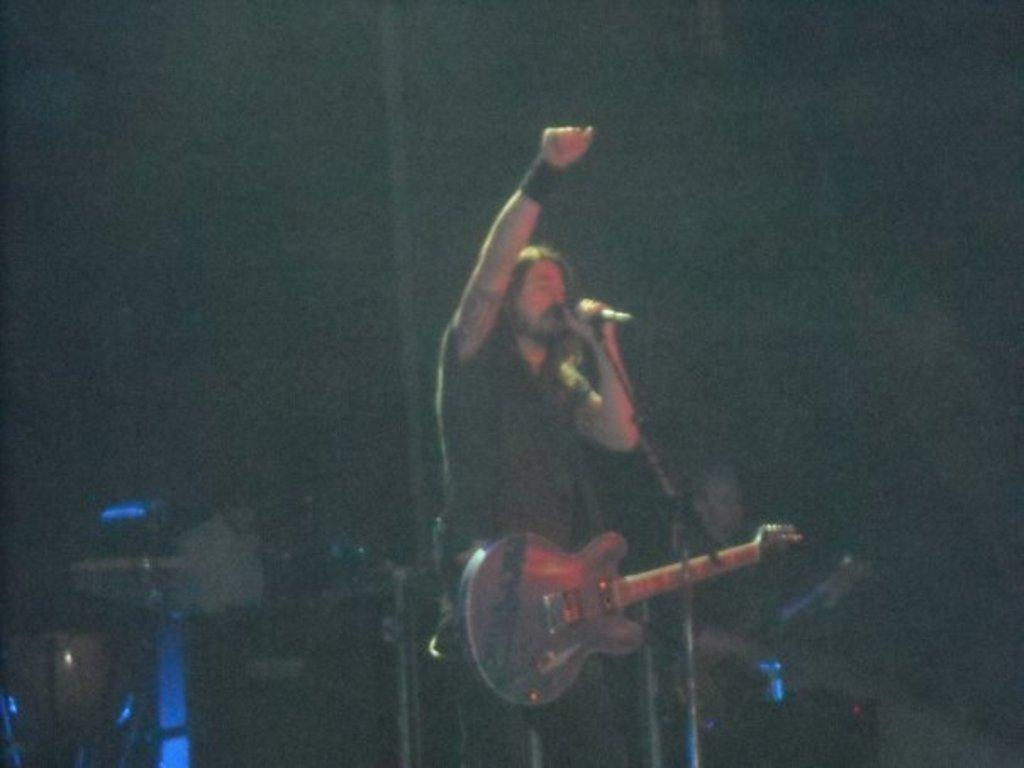What can be observed about the background of the image? The background of the image is dark and blurry. Who is present in the image? There is a man in the image. What is the man doing in the image? The man is standing in front of a microphone and singing. What musical instrument is visible in the image? A: There is a guitar in the image. What accessory is the man wearing on his hand? The man is wearing a black wristband on his hand. What type of pet can be seen playing with the paste in the image? There is no pet or paste present in the image. 